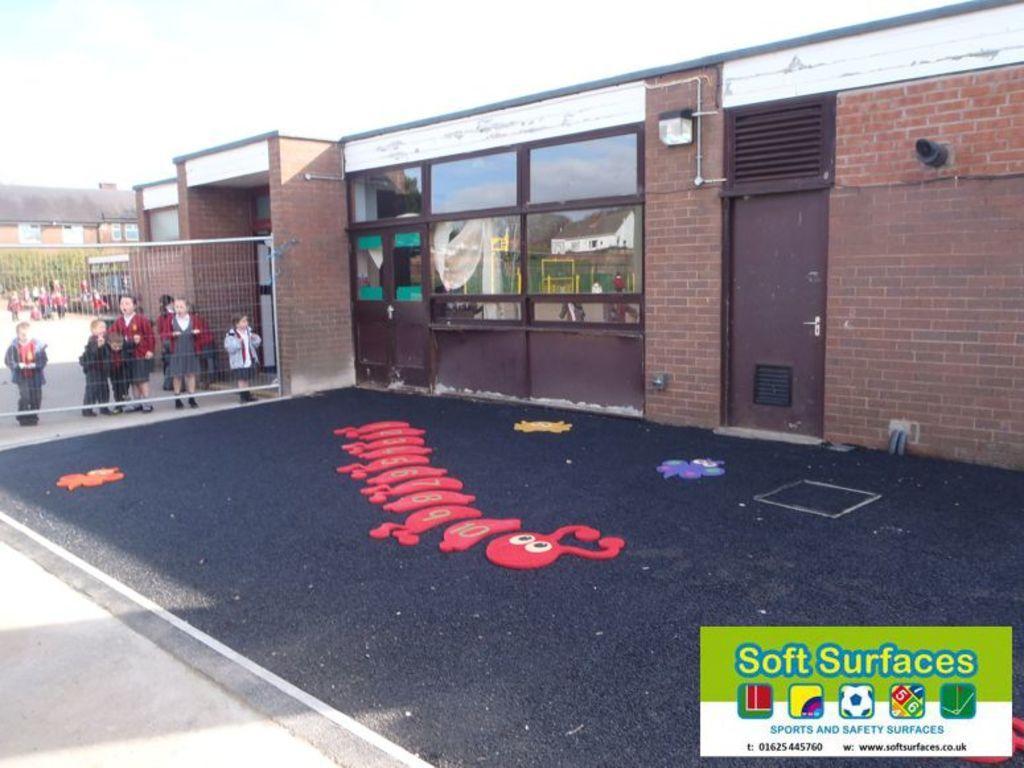How would you summarize this image in a sentence or two? In this image we can see buildings, trees, children standing behind the mesh, toys on the floor, pipelines, glasses and sky in the background. 